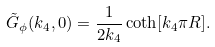<formula> <loc_0><loc_0><loc_500><loc_500>\tilde { G } _ { \phi } ( k _ { 4 } , 0 ) = \frac { 1 } { 2 k _ { 4 } } \coth [ k _ { 4 } \pi R ] .</formula> 